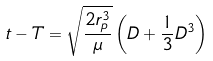Convert formula to latex. <formula><loc_0><loc_0><loc_500><loc_500>t - T = { \sqrt { \frac { 2 r _ { p } ^ { 3 } } { \mu } } } \left ( D + { \frac { 1 } { 3 } } D ^ { 3 } \right )</formula> 